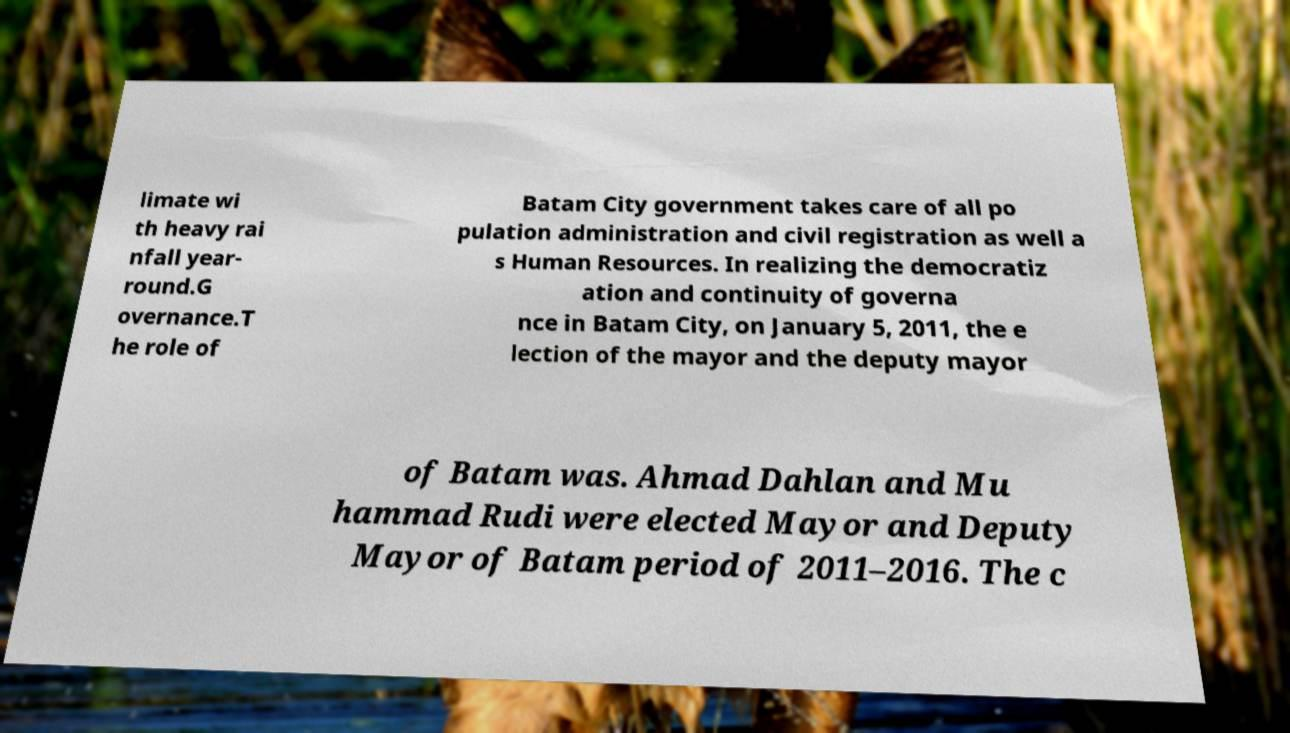I need the written content from this picture converted into text. Can you do that? limate wi th heavy rai nfall year- round.G overnance.T he role of Batam City government takes care of all po pulation administration and civil registration as well a s Human Resources. In realizing the democratiz ation and continuity of governa nce in Batam City, on January 5, 2011, the e lection of the mayor and the deputy mayor of Batam was. Ahmad Dahlan and Mu hammad Rudi were elected Mayor and Deputy Mayor of Batam period of 2011–2016. The c 